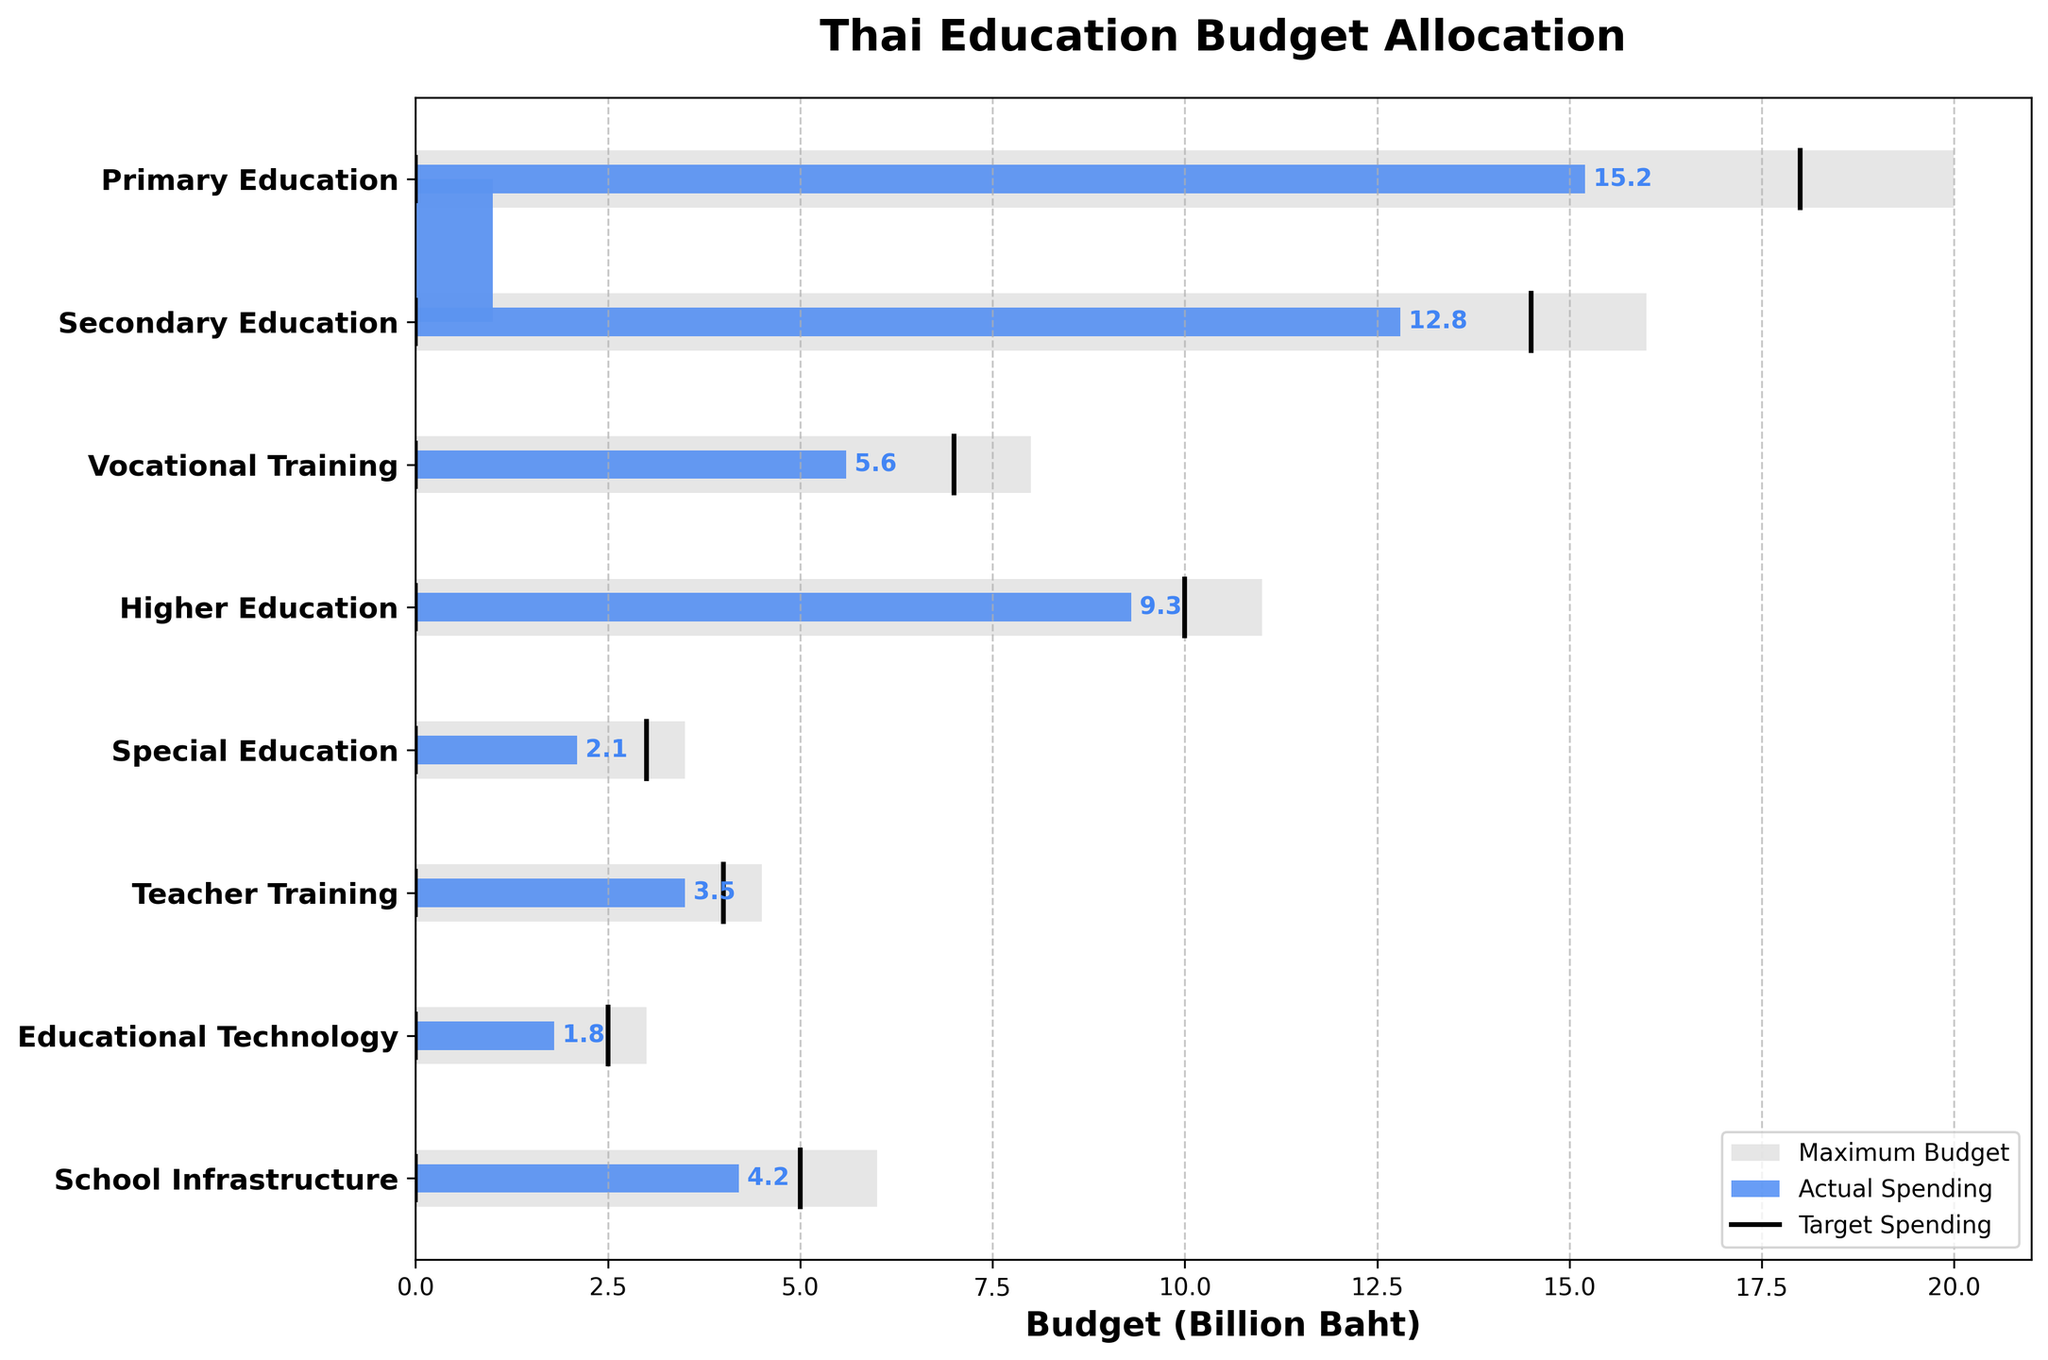What's the title of the chart? The title is typically located at the top of the chart. In this case, it is "Thai Education Budget Allocation" as stated in the code.
Answer: Thai Education Budget Allocation How much is the actual spending on Primary Education? The chart shows the actual spending on different sectors using blue bars. Under "Primary Education", the blue bar represents 15.2 billion Baht.
Answer: 15.2 billion Baht What is the maximum budget allocated for Teacher Training? The maximum budget is represented by the gray bars. For "Teacher Training", the gray bar extends to 4.5 billion Baht.
Answer: 4.5 billion Baht Which sector has the largest difference between actual spending and target spending? To find the largest difference, subtract the actual spending from the target spending for each sector and compare. The differences are: "Primary Education" (2.8), "Secondary Education" (1.7), "Vocational Training" (1.4), "Higher Education" (0.7), "Special Education" (0.9), "Teacher Training" (0.5), "Educational Technology" (0.7), "School Infrastructure" (0.8). The largest difference is in "Primary Education".
Answer: Primary Education Which sector has actual spending equal to or exceeding the target spending? We need to compare the actual spending and target spending for each sector. None of the sectors have actual spending equal to or exceeding the target spending; all blue bars are shorter than their corresponding black line.
Answer: None How much more is the target spending than the actual spending in Secondary Education? Subtract the actual spending from the target spending in "Secondary Education". Target is 14.5 billion Baht and actual is 12.8 billion Baht. 14.5 - 12.8 = 1.7 billion Baht.
Answer: 1.7 billion Baht What is the average maximum budget across all sectors? Sum the maximum budgets and divide by the number of sectors. (20.0 + 16.0 + 8.0 + 11.0 + 3.5 + 4.5 + 3.0 + 6.0) / 8 = (72.0 / 8) = 9.0 billion Baht.
Answer: 9.0 billion Baht Which sector has the smallest actual spending? Locate the shortest blue bar, which represents "Educational Technology" at 1.8 billion Baht.
Answer: Educational Technology How does the actual spending on Higher Education compare to Vocational Training? Compare the blue bars for "Higher Education" and "Vocational Training". Higher Education has 9.3 billion Baht, while Vocational Training has 5.6 billion Baht. Thus, Higher Education has more actual spending.
Answer: Higher Education has more What visual elements are used to represent the target spending in the chart? The target spending is represented by thin black lines. Each line is drawn along the y-axis corresponding to the sector.
Answer: Thin black lines 